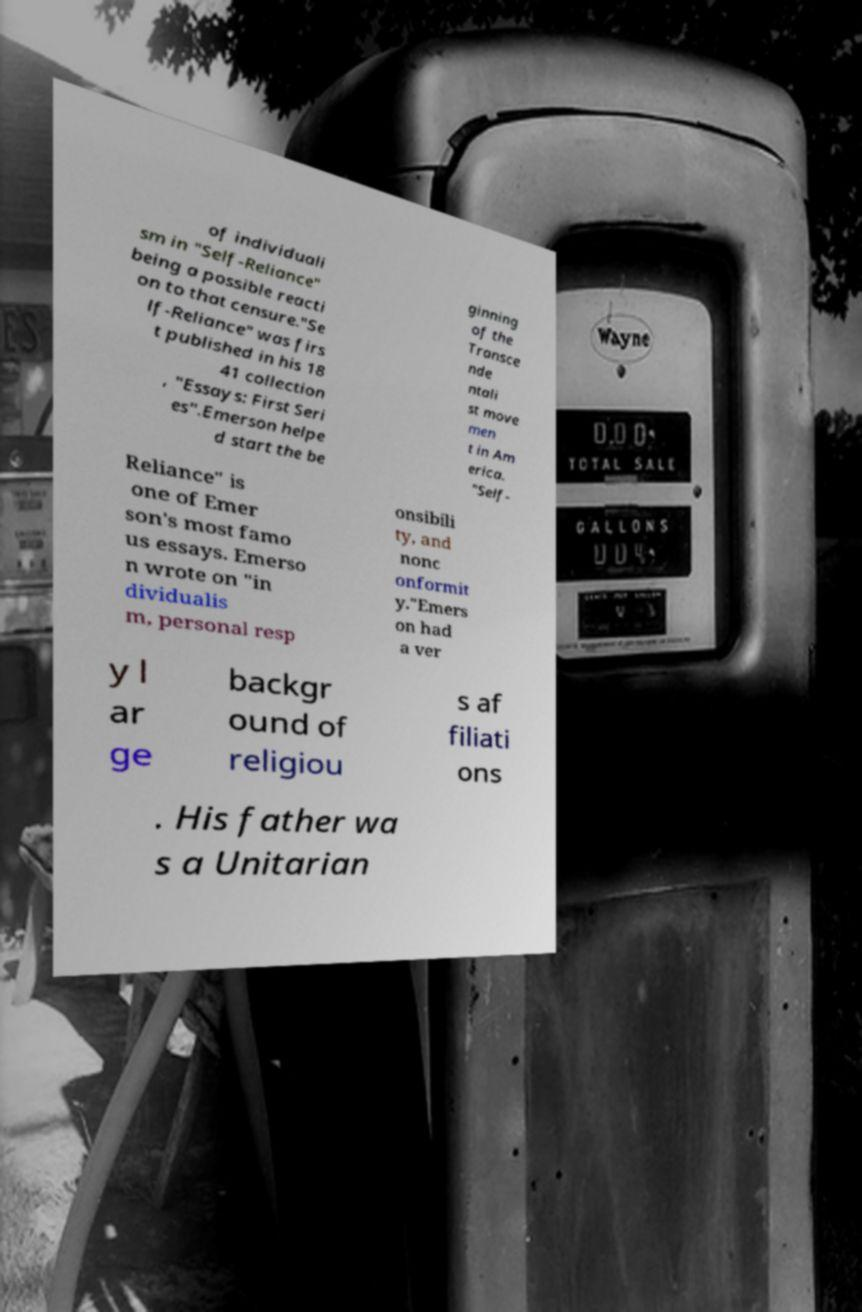Could you assist in decoding the text presented in this image and type it out clearly? of individuali sm in "Self-Reliance" being a possible reacti on to that censure."Se lf-Reliance" was firs t published in his 18 41 collection , "Essays: First Seri es".Emerson helpe d start the be ginning of the Transce nde ntali st move men t in Am erica. "Self- Reliance" is one of Emer son's most famo us essays. Emerso n wrote on "in dividualis m, personal resp onsibili ty, and nonc onformit y."Emers on had a ver y l ar ge backgr ound of religiou s af filiati ons . His father wa s a Unitarian 